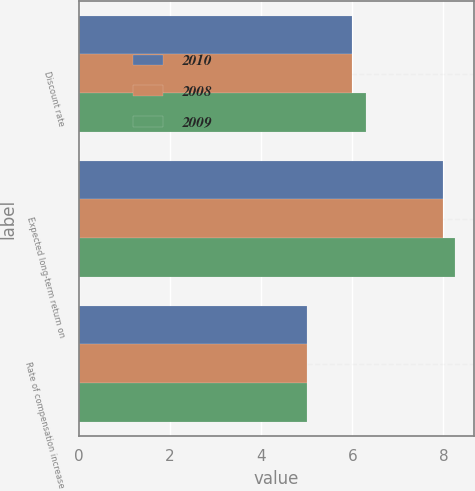<chart> <loc_0><loc_0><loc_500><loc_500><stacked_bar_chart><ecel><fcel>Discount rate<fcel>Expected long-term return on<fcel>Rate of compensation increase<nl><fcel>2010<fcel>6<fcel>8<fcel>5<nl><fcel>2008<fcel>6<fcel>8<fcel>5<nl><fcel>2009<fcel>6.3<fcel>8.25<fcel>5<nl></chart> 